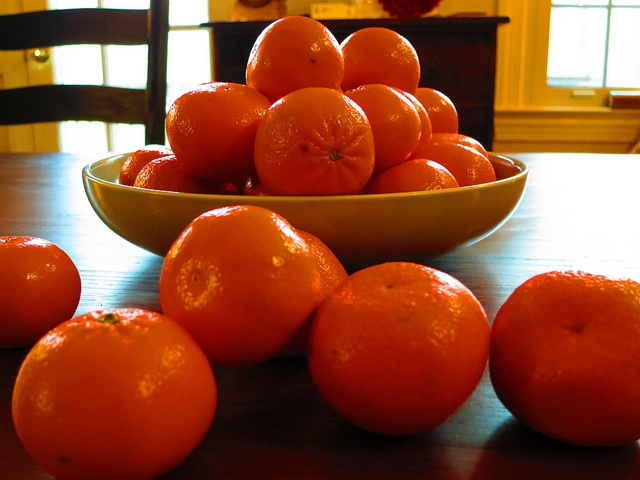Describe the objects in this image and their specific colors. I can see dining table in orange, black, white, maroon, and lightblue tones, orange in orange, brown, red, and maroon tones, orange in orange, maroon, and red tones, orange in orange, maroon, and red tones, and orange in orange, maroon, black, and red tones in this image. 